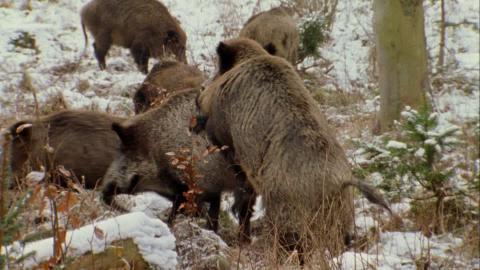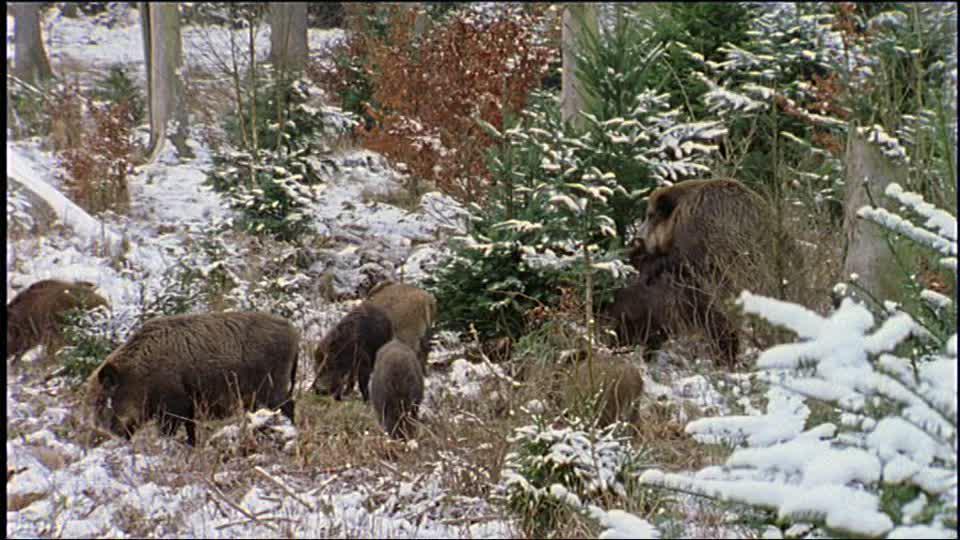The first image is the image on the left, the second image is the image on the right. For the images shown, is this caption "Only one image has animals in the snow." true? Answer yes or no. No. 